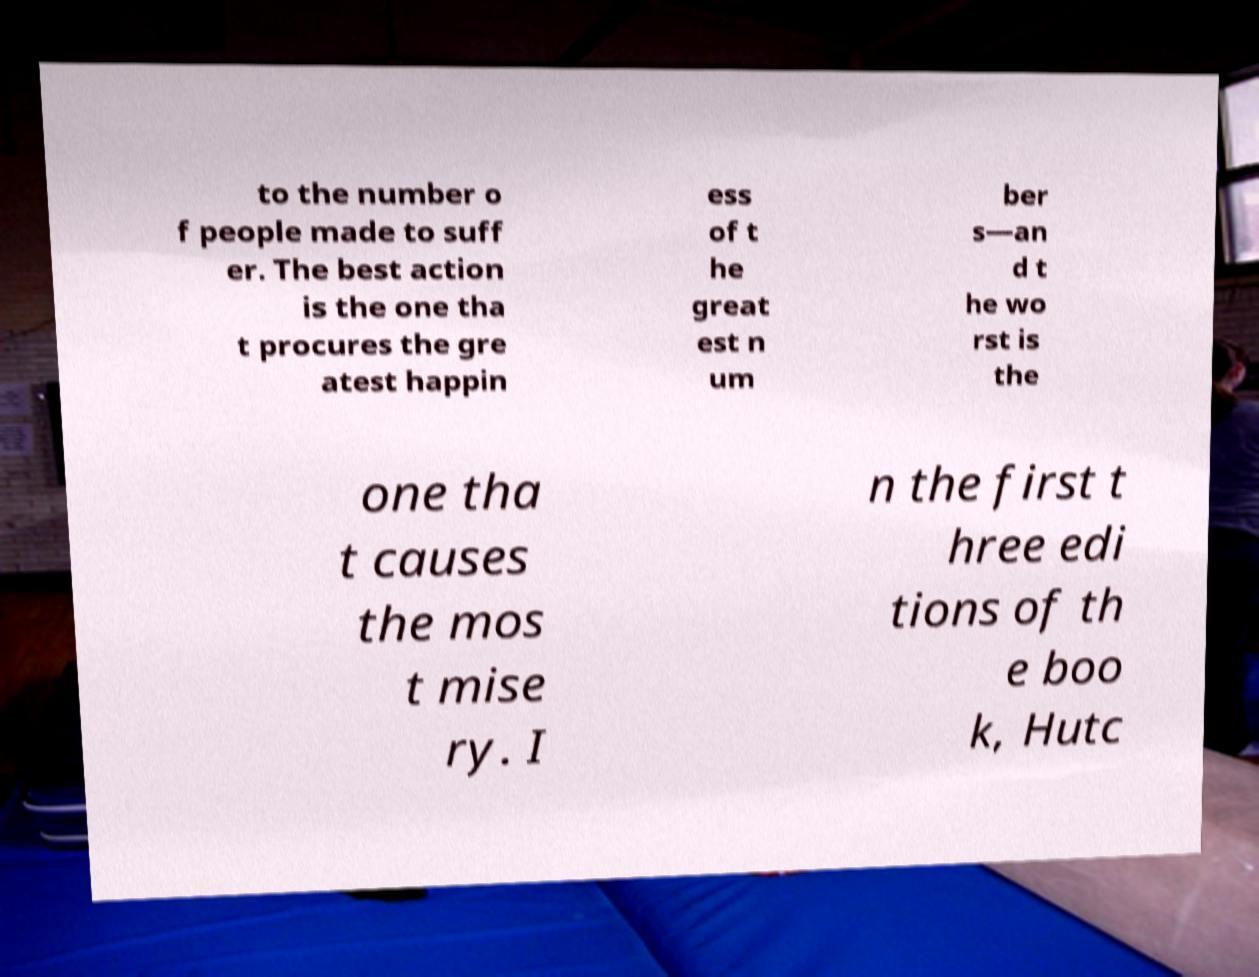Please identify and transcribe the text found in this image. to the number o f people made to suff er. The best action is the one tha t procures the gre atest happin ess of t he great est n um ber s—an d t he wo rst is the one tha t causes the mos t mise ry. I n the first t hree edi tions of th e boo k, Hutc 